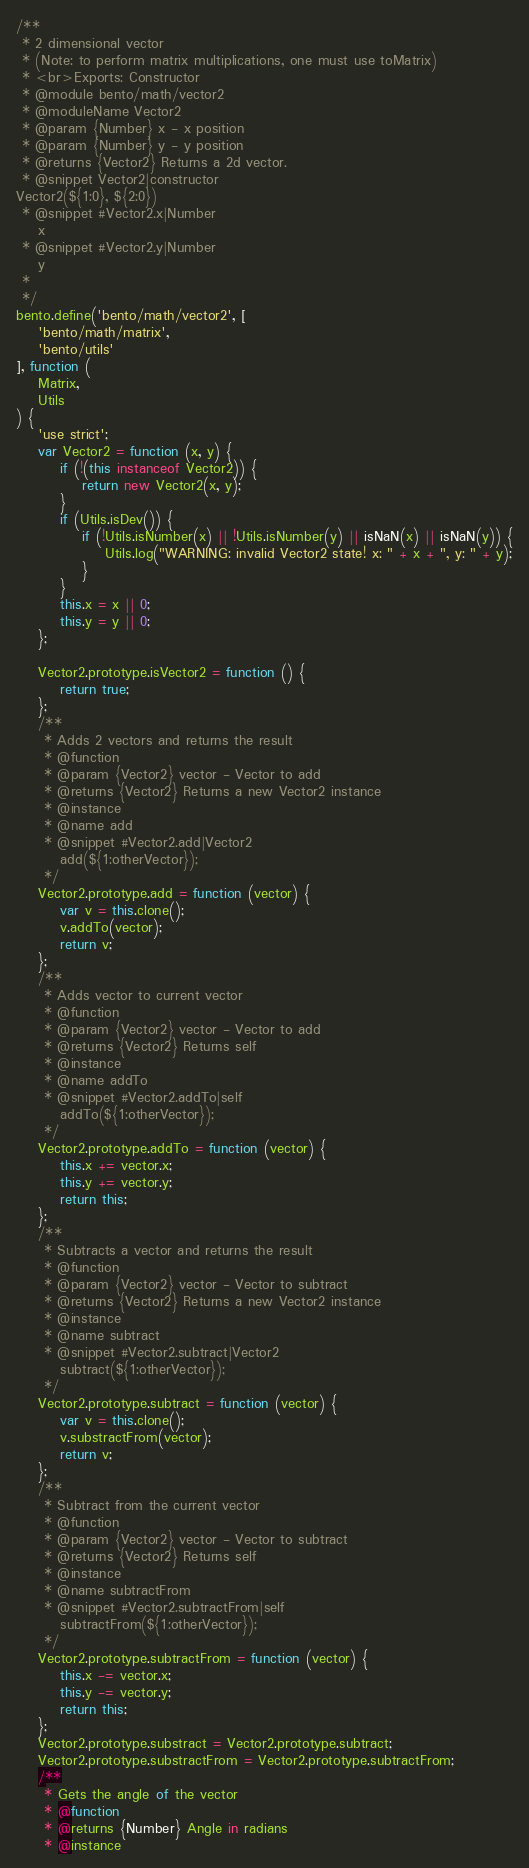Convert code to text. <code><loc_0><loc_0><loc_500><loc_500><_JavaScript_>/**
 * 2 dimensional vector
 * (Note: to perform matrix multiplications, one must use toMatrix)
 * <br>Exports: Constructor
 * @module bento/math/vector2
 * @moduleName Vector2
 * @param {Number} x - x position
 * @param {Number} y - y position
 * @returns {Vector2} Returns a 2d vector.
 * @snippet Vector2|constructor
Vector2(${1:0}, ${2:0})
 * @snippet #Vector2.x|Number
    x
 * @snippet #Vector2.y|Number
    y
 *
 */
bento.define('bento/math/vector2', [
    'bento/math/matrix',
    'bento/utils'
], function (
    Matrix,
    Utils
) {
    'use strict';
    var Vector2 = function (x, y) {
        if (!(this instanceof Vector2)) {
            return new Vector2(x, y);
        }
        if (Utils.isDev()) {
            if (!Utils.isNumber(x) || !Utils.isNumber(y) || isNaN(x) || isNaN(y)) {
                Utils.log("WARNING: invalid Vector2 state! x: " + x + ", y: " + y);
            }
        }
        this.x = x || 0;
        this.y = y || 0;
    };

    Vector2.prototype.isVector2 = function () {
        return true;
    };
    /**
     * Adds 2 vectors and returns the result
     * @function
     * @param {Vector2} vector - Vector to add
     * @returns {Vector2} Returns a new Vector2 instance
     * @instance
     * @name add
     * @snippet #Vector2.add|Vector2
        add(${1:otherVector});
     */
    Vector2.prototype.add = function (vector) {
        var v = this.clone();
        v.addTo(vector);
        return v;
    };
    /**
     * Adds vector to current vector
     * @function
     * @param {Vector2} vector - Vector to add
     * @returns {Vector2} Returns self
     * @instance
     * @name addTo
     * @snippet #Vector2.addTo|self
        addTo(${1:otherVector});
     */
    Vector2.prototype.addTo = function (vector) {
        this.x += vector.x;
        this.y += vector.y;
        return this;
    };
    /**
     * Subtracts a vector and returns the result
     * @function
     * @param {Vector2} vector - Vector to subtract
     * @returns {Vector2} Returns a new Vector2 instance
     * @instance
     * @name subtract
     * @snippet #Vector2.subtract|Vector2
        subtract(${1:otherVector});
     */
    Vector2.prototype.subtract = function (vector) {
        var v = this.clone();
        v.substractFrom(vector);
        return v;
    };
    /**
     * Subtract from the current vector
     * @function
     * @param {Vector2} vector - Vector to subtract
     * @returns {Vector2} Returns self
     * @instance
     * @name subtractFrom
     * @snippet #Vector2.subtractFrom|self
        subtractFrom(${1:otherVector});
     */
    Vector2.prototype.subtractFrom = function (vector) {
        this.x -= vector.x;
        this.y -= vector.y;
        return this;
    };
    Vector2.prototype.substract = Vector2.prototype.subtract;
    Vector2.prototype.substractFrom = Vector2.prototype.subtractFrom;
    /**
     * Gets the angle of the vector
     * @function
     * @returns {Number} Angle in radians
     * @instance</code> 